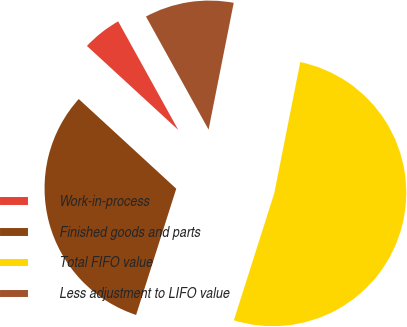Convert chart to OTSL. <chart><loc_0><loc_0><loc_500><loc_500><pie_chart><fcel>Work-in-process<fcel>Finished goods and parts<fcel>Total FIFO value<fcel>Less adjustment to LIFO value<nl><fcel>5.12%<fcel>31.93%<fcel>51.78%<fcel>11.16%<nl></chart> 